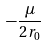<formula> <loc_0><loc_0><loc_500><loc_500>- \frac { \mu } { 2 r _ { 0 } }</formula> 